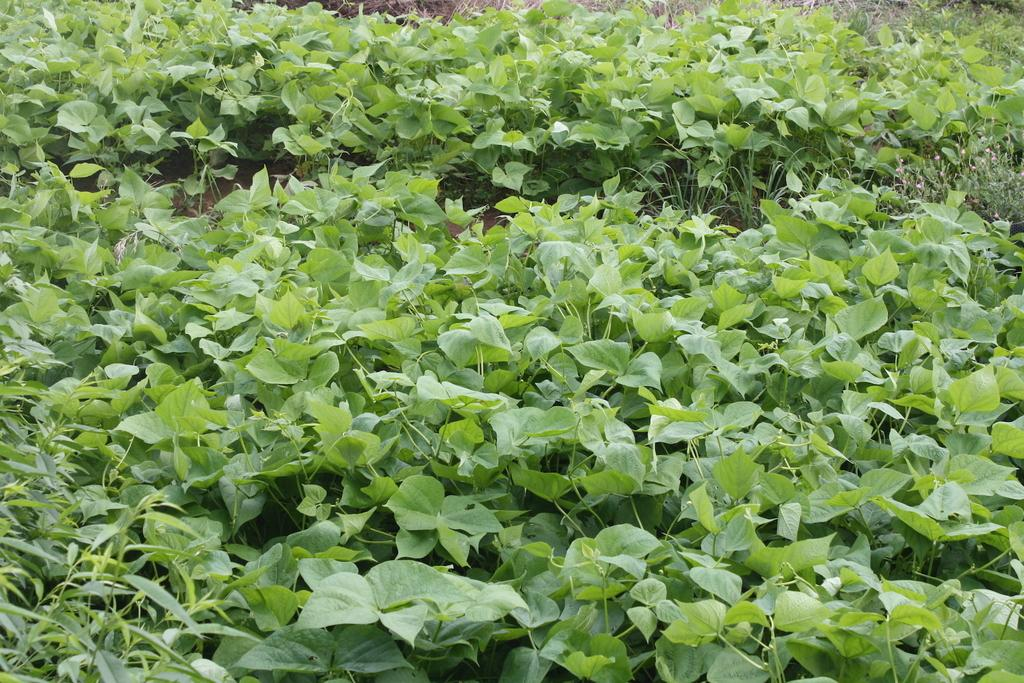What type of vegetation can be seen in the image? There are plants and grass in the image. What else is present in the image besides vegetation? There are other objects in the image. What type of frame is visible in the image? There is no frame present in the image. How many planes can be seen flying in the image? There are no planes visible in the image. 